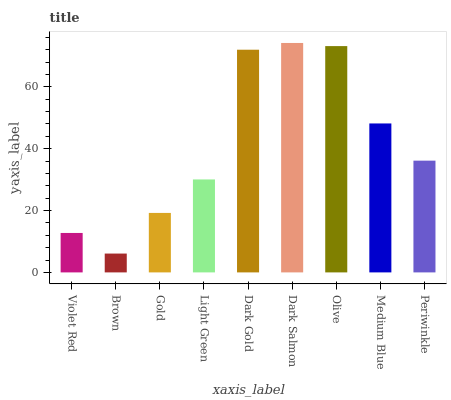Is Brown the minimum?
Answer yes or no. Yes. Is Dark Salmon the maximum?
Answer yes or no. Yes. Is Gold the minimum?
Answer yes or no. No. Is Gold the maximum?
Answer yes or no. No. Is Gold greater than Brown?
Answer yes or no. Yes. Is Brown less than Gold?
Answer yes or no. Yes. Is Brown greater than Gold?
Answer yes or no. No. Is Gold less than Brown?
Answer yes or no. No. Is Periwinkle the high median?
Answer yes or no. Yes. Is Periwinkle the low median?
Answer yes or no. Yes. Is Dark Gold the high median?
Answer yes or no. No. Is Dark Salmon the low median?
Answer yes or no. No. 